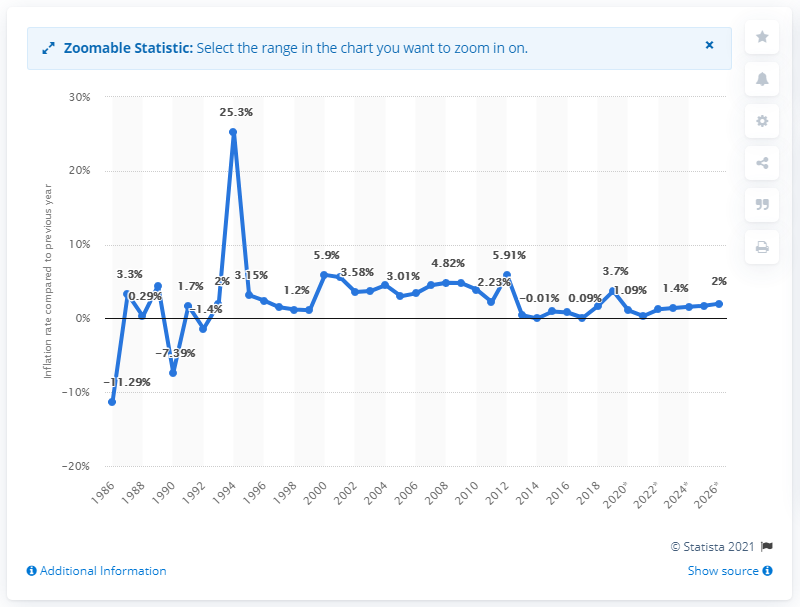Can you explain the spike in inflation in 1980 shown in this chart? The significant spike in inflation in 1980, showing a 25.3% increase, likely reflects economic instability potentially due to external or internal factors such as oil price shocks or political instability during that period. 